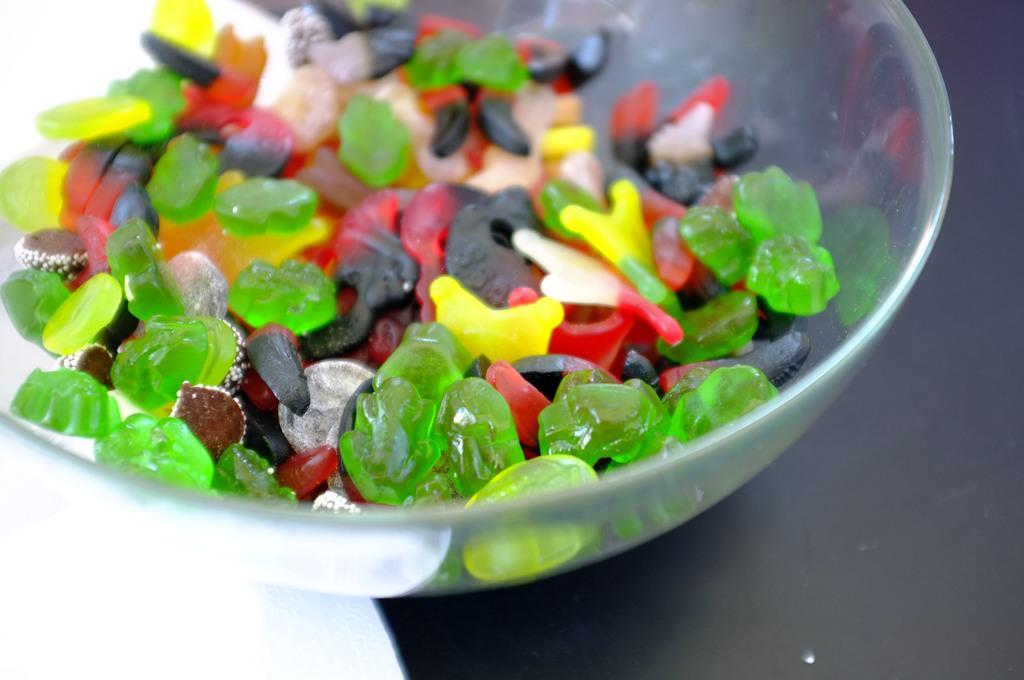In one or two sentences, can you explain what this image depicts? In this image I can see a candy in the glass bowl. They are in different color. 